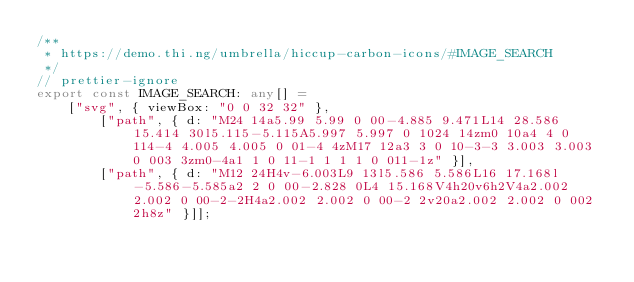<code> <loc_0><loc_0><loc_500><loc_500><_TypeScript_>/**
 * https://demo.thi.ng/umbrella/hiccup-carbon-icons/#IMAGE_SEARCH
 */
// prettier-ignore
export const IMAGE_SEARCH: any[] =
    ["svg", { viewBox: "0 0 32 32" },
        ["path", { d: "M24 14a5.99 5.99 0 00-4.885 9.471L14 28.586 15.414 30l5.115-5.115A5.997 5.997 0 1024 14zm0 10a4 4 0 114-4 4.005 4.005 0 01-4 4zM17 12a3 3 0 10-3-3 3.003 3.003 0 003 3zm0-4a1 1 0 11-1 1 1 1 0 011-1z" }],
        ["path", { d: "M12 24H4v-6.003L9 13l5.586 5.586L16 17.168l-5.586-5.585a2 2 0 00-2.828 0L4 15.168V4h20v6h2V4a2.002 2.002 0 00-2-2H4a2.002 2.002 0 00-2 2v20a2.002 2.002 0 002 2h8z" }]];
</code> 